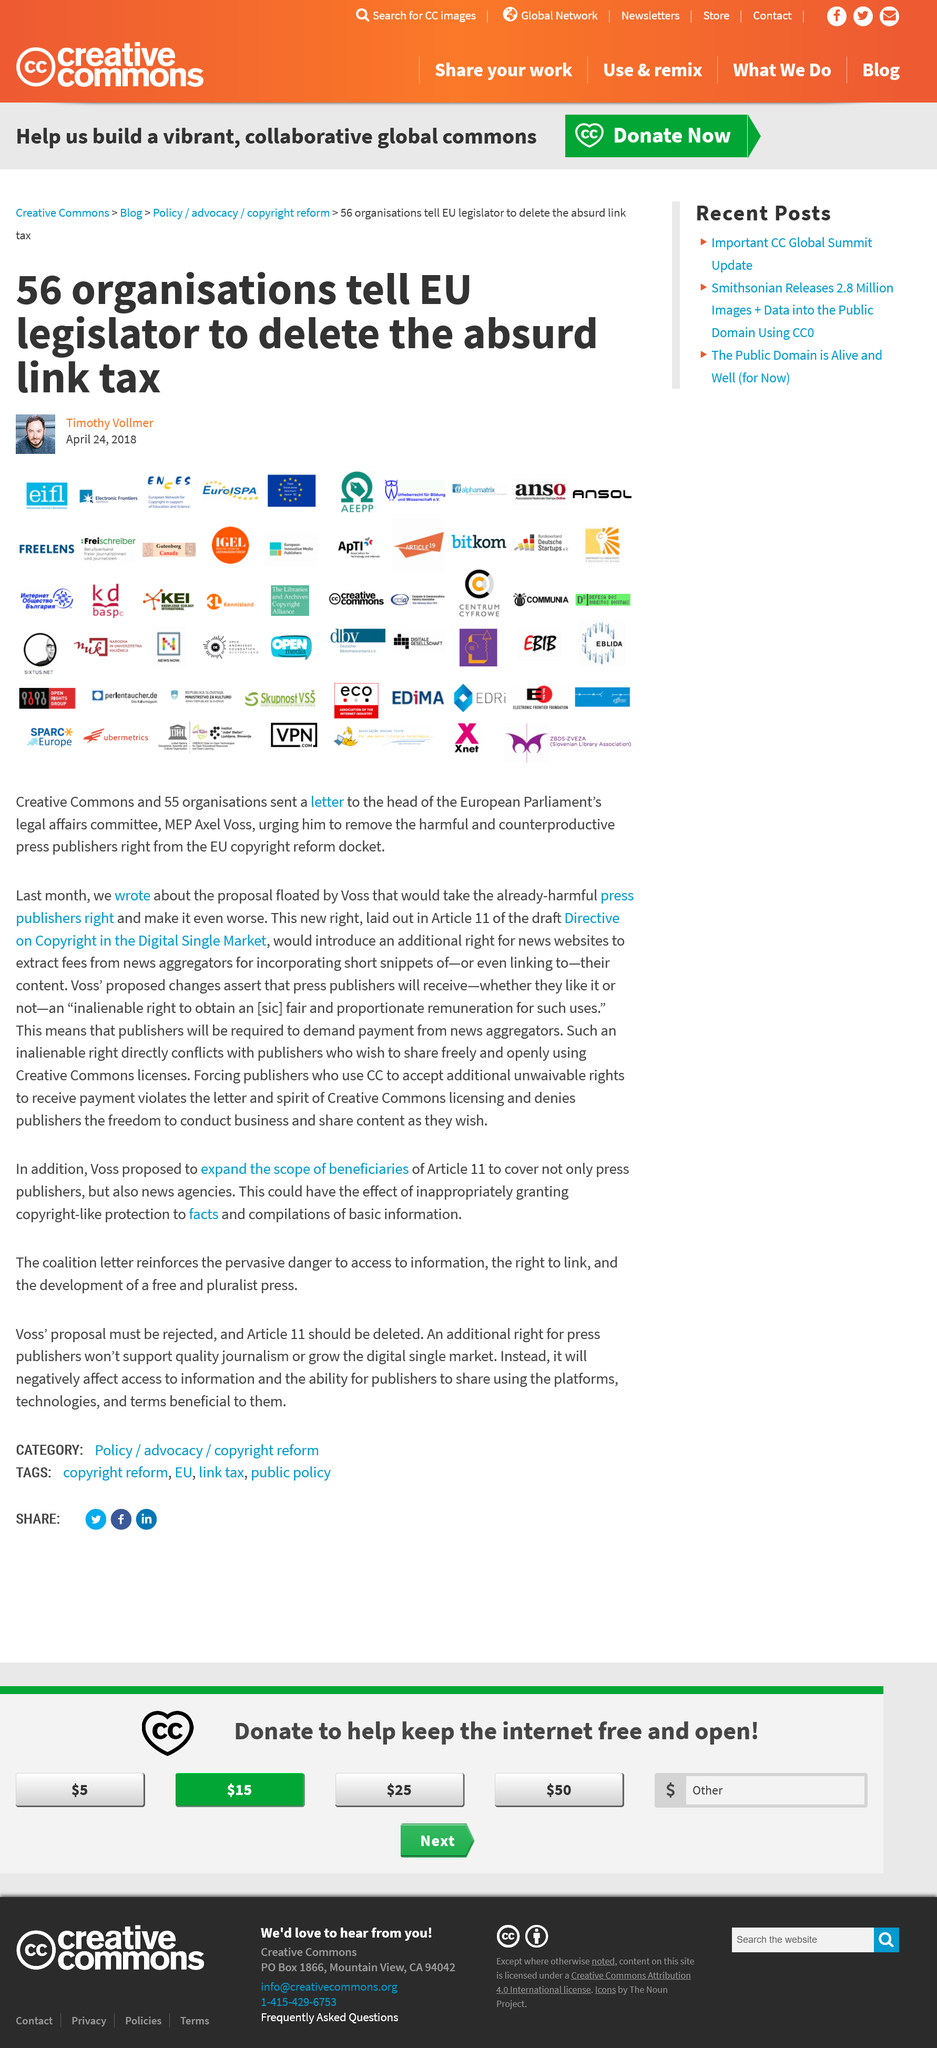Point out several critical features in this image. The letter was received by Axel Voss from the organizations. The actions of the 56 organizations were reported on April 24, 2018. The organization with the logo featuring an orange circle with letters inside, IGEL, was one of the 56 organizations that signed the letter. 